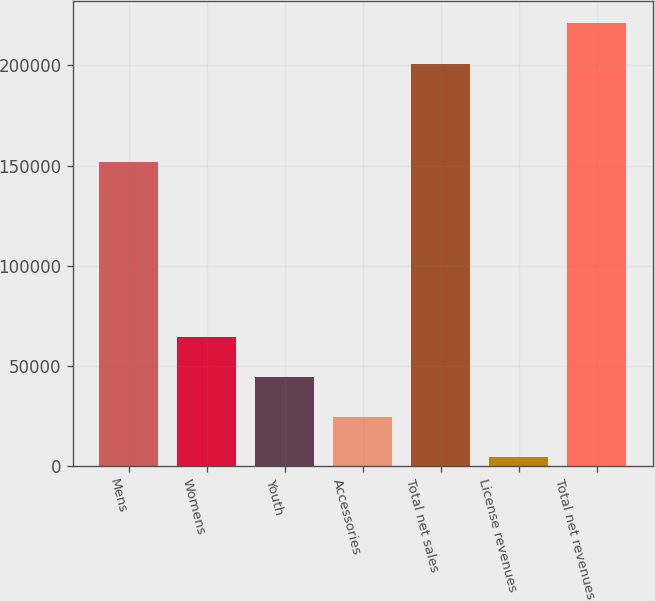Convert chart to OTSL. <chart><loc_0><loc_0><loc_500><loc_500><bar_chart><fcel>Mens<fcel>Womens<fcel>Youth<fcel>Accessories<fcel>Total net sales<fcel>License revenues<fcel>Total net revenues<nl><fcel>151962<fcel>64569.2<fcel>44481.8<fcel>24394.4<fcel>200874<fcel>4307<fcel>220961<nl></chart> 